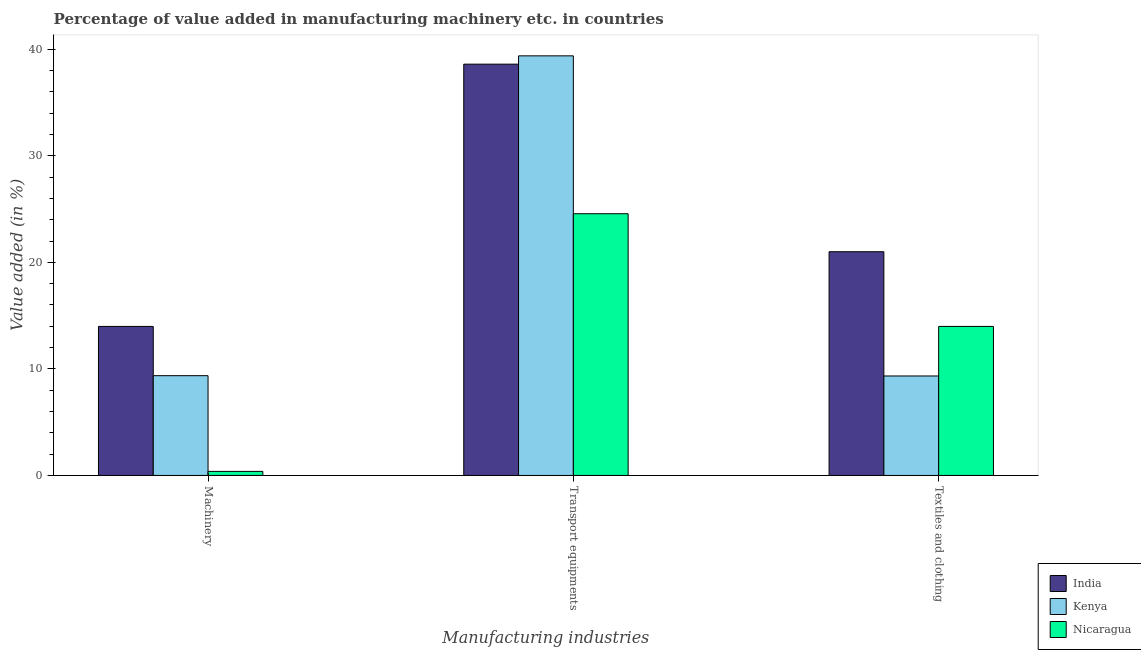How many groups of bars are there?
Offer a very short reply. 3. Are the number of bars per tick equal to the number of legend labels?
Keep it short and to the point. Yes. Are the number of bars on each tick of the X-axis equal?
Offer a very short reply. Yes. How many bars are there on the 2nd tick from the right?
Offer a very short reply. 3. What is the label of the 1st group of bars from the left?
Keep it short and to the point. Machinery. What is the value added in manufacturing textile and clothing in India?
Give a very brief answer. 21. Across all countries, what is the maximum value added in manufacturing transport equipments?
Ensure brevity in your answer.  39.39. Across all countries, what is the minimum value added in manufacturing textile and clothing?
Provide a short and direct response. 9.34. In which country was the value added in manufacturing textile and clothing minimum?
Provide a succinct answer. Kenya. What is the total value added in manufacturing machinery in the graph?
Offer a very short reply. 23.73. What is the difference between the value added in manufacturing machinery in Nicaragua and that in Kenya?
Provide a succinct answer. -8.99. What is the difference between the value added in manufacturing machinery in Kenya and the value added in manufacturing textile and clothing in Nicaragua?
Your response must be concise. -4.62. What is the average value added in manufacturing machinery per country?
Your answer should be very brief. 7.91. What is the difference between the value added in manufacturing machinery and value added in manufacturing transport equipments in India?
Your answer should be very brief. -24.62. In how many countries, is the value added in manufacturing transport equipments greater than 26 %?
Give a very brief answer. 2. What is the ratio of the value added in manufacturing machinery in Kenya to that in India?
Give a very brief answer. 0.67. Is the difference between the value added in manufacturing transport equipments in Nicaragua and India greater than the difference between the value added in manufacturing machinery in Nicaragua and India?
Provide a succinct answer. No. What is the difference between the highest and the second highest value added in manufacturing textile and clothing?
Make the answer very short. 7.01. What is the difference between the highest and the lowest value added in manufacturing transport equipments?
Ensure brevity in your answer.  14.82. In how many countries, is the value added in manufacturing transport equipments greater than the average value added in manufacturing transport equipments taken over all countries?
Offer a terse response. 2. What does the 2nd bar from the left in Machinery represents?
Provide a succinct answer. Kenya. What does the 3rd bar from the right in Machinery represents?
Provide a succinct answer. India. How many bars are there?
Give a very brief answer. 9. Are all the bars in the graph horizontal?
Make the answer very short. No. How many countries are there in the graph?
Offer a very short reply. 3. What is the difference between two consecutive major ticks on the Y-axis?
Offer a terse response. 10. Where does the legend appear in the graph?
Your answer should be compact. Bottom right. How many legend labels are there?
Your answer should be very brief. 3. How are the legend labels stacked?
Offer a very short reply. Vertical. What is the title of the graph?
Your answer should be compact. Percentage of value added in manufacturing machinery etc. in countries. Does "Cabo Verde" appear as one of the legend labels in the graph?
Your response must be concise. No. What is the label or title of the X-axis?
Your response must be concise. Manufacturing industries. What is the label or title of the Y-axis?
Your response must be concise. Value added (in %). What is the Value added (in %) in India in Machinery?
Your answer should be very brief. 13.99. What is the Value added (in %) in Kenya in Machinery?
Provide a short and direct response. 9.37. What is the Value added (in %) of Nicaragua in Machinery?
Your response must be concise. 0.38. What is the Value added (in %) of India in Transport equipments?
Your answer should be very brief. 38.61. What is the Value added (in %) in Kenya in Transport equipments?
Your response must be concise. 39.39. What is the Value added (in %) of Nicaragua in Transport equipments?
Your answer should be compact. 24.57. What is the Value added (in %) of India in Textiles and clothing?
Your answer should be very brief. 21. What is the Value added (in %) of Kenya in Textiles and clothing?
Ensure brevity in your answer.  9.34. What is the Value added (in %) of Nicaragua in Textiles and clothing?
Your answer should be very brief. 13.99. Across all Manufacturing industries, what is the maximum Value added (in %) in India?
Give a very brief answer. 38.61. Across all Manufacturing industries, what is the maximum Value added (in %) in Kenya?
Keep it short and to the point. 39.39. Across all Manufacturing industries, what is the maximum Value added (in %) in Nicaragua?
Offer a very short reply. 24.57. Across all Manufacturing industries, what is the minimum Value added (in %) of India?
Ensure brevity in your answer.  13.99. Across all Manufacturing industries, what is the minimum Value added (in %) in Kenya?
Your response must be concise. 9.34. Across all Manufacturing industries, what is the minimum Value added (in %) of Nicaragua?
Give a very brief answer. 0.38. What is the total Value added (in %) in India in the graph?
Make the answer very short. 73.6. What is the total Value added (in %) in Kenya in the graph?
Give a very brief answer. 58.09. What is the total Value added (in %) of Nicaragua in the graph?
Make the answer very short. 38.94. What is the difference between the Value added (in %) of India in Machinery and that in Transport equipments?
Give a very brief answer. -24.62. What is the difference between the Value added (in %) of Kenya in Machinery and that in Transport equipments?
Offer a terse response. -30.02. What is the difference between the Value added (in %) in Nicaragua in Machinery and that in Transport equipments?
Offer a terse response. -24.19. What is the difference between the Value added (in %) of India in Machinery and that in Textiles and clothing?
Offer a terse response. -7.01. What is the difference between the Value added (in %) of Kenya in Machinery and that in Textiles and clothing?
Your response must be concise. 0.03. What is the difference between the Value added (in %) of Nicaragua in Machinery and that in Textiles and clothing?
Provide a succinct answer. -13.61. What is the difference between the Value added (in %) in India in Transport equipments and that in Textiles and clothing?
Provide a succinct answer. 17.61. What is the difference between the Value added (in %) of Kenya in Transport equipments and that in Textiles and clothing?
Offer a very short reply. 30.05. What is the difference between the Value added (in %) of Nicaragua in Transport equipments and that in Textiles and clothing?
Ensure brevity in your answer.  10.58. What is the difference between the Value added (in %) in India in Machinery and the Value added (in %) in Kenya in Transport equipments?
Your response must be concise. -25.4. What is the difference between the Value added (in %) in India in Machinery and the Value added (in %) in Nicaragua in Transport equipments?
Your response must be concise. -10.58. What is the difference between the Value added (in %) of Kenya in Machinery and the Value added (in %) of Nicaragua in Transport equipments?
Your answer should be very brief. -15.2. What is the difference between the Value added (in %) of India in Machinery and the Value added (in %) of Kenya in Textiles and clothing?
Give a very brief answer. 4.65. What is the difference between the Value added (in %) in India in Machinery and the Value added (in %) in Nicaragua in Textiles and clothing?
Offer a very short reply. -0. What is the difference between the Value added (in %) of Kenya in Machinery and the Value added (in %) of Nicaragua in Textiles and clothing?
Provide a short and direct response. -4.62. What is the difference between the Value added (in %) of India in Transport equipments and the Value added (in %) of Kenya in Textiles and clothing?
Your answer should be very brief. 29.27. What is the difference between the Value added (in %) of India in Transport equipments and the Value added (in %) of Nicaragua in Textiles and clothing?
Offer a terse response. 24.62. What is the difference between the Value added (in %) in Kenya in Transport equipments and the Value added (in %) in Nicaragua in Textiles and clothing?
Keep it short and to the point. 25.4. What is the average Value added (in %) in India per Manufacturing industries?
Provide a succinct answer. 24.53. What is the average Value added (in %) in Kenya per Manufacturing industries?
Give a very brief answer. 19.36. What is the average Value added (in %) of Nicaragua per Manufacturing industries?
Give a very brief answer. 12.98. What is the difference between the Value added (in %) of India and Value added (in %) of Kenya in Machinery?
Your answer should be compact. 4.62. What is the difference between the Value added (in %) of India and Value added (in %) of Nicaragua in Machinery?
Offer a very short reply. 13.61. What is the difference between the Value added (in %) in Kenya and Value added (in %) in Nicaragua in Machinery?
Your answer should be very brief. 8.99. What is the difference between the Value added (in %) of India and Value added (in %) of Kenya in Transport equipments?
Your response must be concise. -0.78. What is the difference between the Value added (in %) of India and Value added (in %) of Nicaragua in Transport equipments?
Your response must be concise. 14.04. What is the difference between the Value added (in %) in Kenya and Value added (in %) in Nicaragua in Transport equipments?
Give a very brief answer. 14.82. What is the difference between the Value added (in %) in India and Value added (in %) in Kenya in Textiles and clothing?
Provide a short and direct response. 11.66. What is the difference between the Value added (in %) of India and Value added (in %) of Nicaragua in Textiles and clothing?
Ensure brevity in your answer.  7.01. What is the difference between the Value added (in %) of Kenya and Value added (in %) of Nicaragua in Textiles and clothing?
Your response must be concise. -4.65. What is the ratio of the Value added (in %) in India in Machinery to that in Transport equipments?
Provide a succinct answer. 0.36. What is the ratio of the Value added (in %) of Kenya in Machinery to that in Transport equipments?
Your answer should be very brief. 0.24. What is the ratio of the Value added (in %) of Nicaragua in Machinery to that in Transport equipments?
Offer a very short reply. 0.02. What is the ratio of the Value added (in %) of India in Machinery to that in Textiles and clothing?
Provide a succinct answer. 0.67. What is the ratio of the Value added (in %) in Kenya in Machinery to that in Textiles and clothing?
Make the answer very short. 1. What is the ratio of the Value added (in %) in Nicaragua in Machinery to that in Textiles and clothing?
Your answer should be compact. 0.03. What is the ratio of the Value added (in %) of India in Transport equipments to that in Textiles and clothing?
Give a very brief answer. 1.84. What is the ratio of the Value added (in %) in Kenya in Transport equipments to that in Textiles and clothing?
Ensure brevity in your answer.  4.22. What is the ratio of the Value added (in %) in Nicaragua in Transport equipments to that in Textiles and clothing?
Keep it short and to the point. 1.76. What is the difference between the highest and the second highest Value added (in %) of India?
Make the answer very short. 17.61. What is the difference between the highest and the second highest Value added (in %) of Kenya?
Your answer should be very brief. 30.02. What is the difference between the highest and the second highest Value added (in %) in Nicaragua?
Offer a very short reply. 10.58. What is the difference between the highest and the lowest Value added (in %) in India?
Provide a short and direct response. 24.62. What is the difference between the highest and the lowest Value added (in %) of Kenya?
Offer a very short reply. 30.05. What is the difference between the highest and the lowest Value added (in %) in Nicaragua?
Provide a short and direct response. 24.19. 